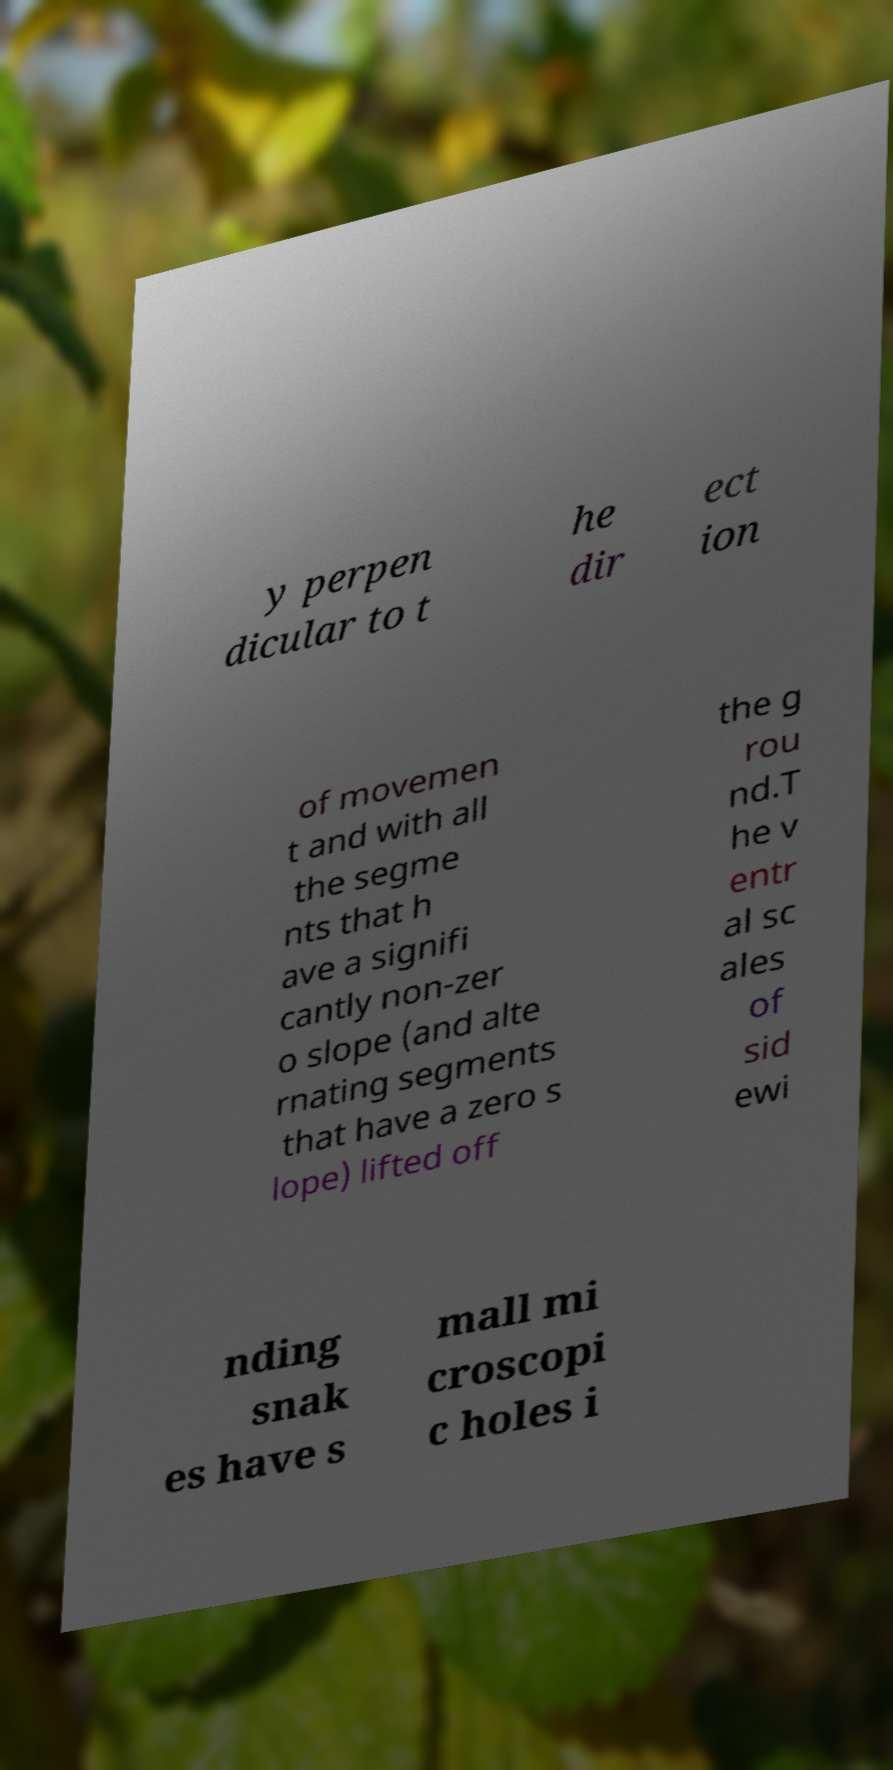What messages or text are displayed in this image? I need them in a readable, typed format. y perpen dicular to t he dir ect ion of movemen t and with all the segme nts that h ave a signifi cantly non-zer o slope (and alte rnating segments that have a zero s lope) lifted off the g rou nd.T he v entr al sc ales of sid ewi nding snak es have s mall mi croscopi c holes i 